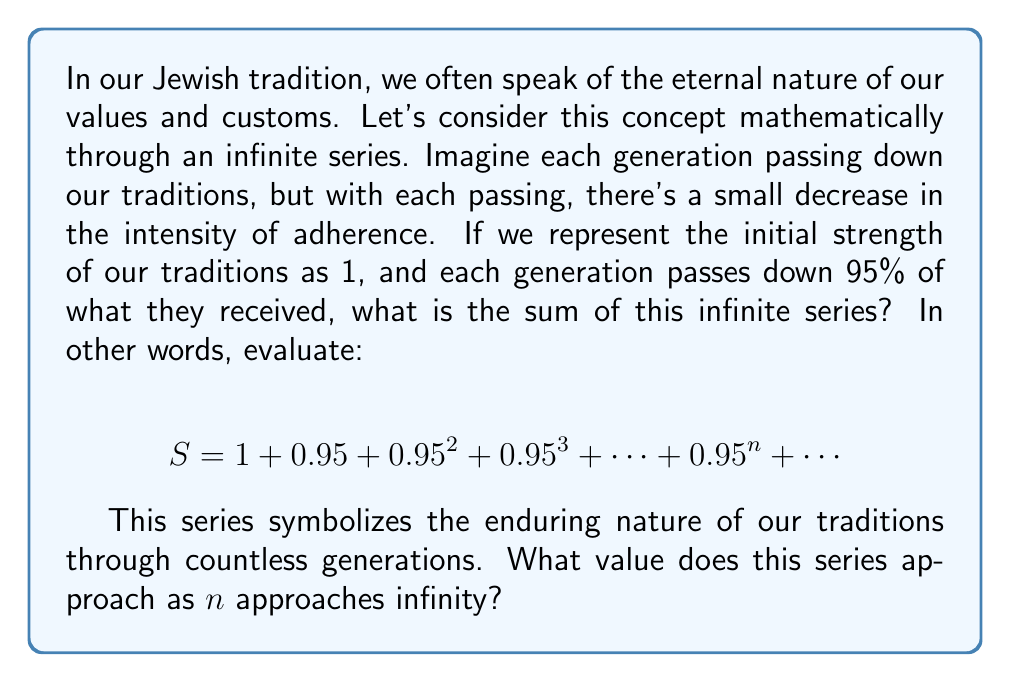Could you help me with this problem? To solve this problem, we'll use the formula for the sum of an infinite geometric series. Let's break it down step-by-step:

1) First, recall the formula for the sum of an infinite geometric series:

   $$ S_{\infty} = \frac{a}{1-r} $$

   Where $a$ is the first term and $r$ is the common ratio between terms.

2) In our series:
   - The first term, $a = 1$
   - The common ratio, $r = 0.95$

3) Let's check if $|r| < 1$, which is necessary for the series to converge:
   
   $|0.95| = 0.95 < 1$, so the series converges.

4) Now, let's substitute these values into our formula:

   $$ S_{\infty} = \frac{1}{1-0.95} = \frac{1}{0.05} = 20 $$

5) Therefore, the sum of this infinite series is 20.

This result has a beautiful interpretation in our context: Despite the gradual decrease in each generation, the cumulative impact of our traditions over infinite generations is finite and substantial - 20 times the initial strength. This symbolizes how our values and traditions, though slightly diminished in each passing, maintain a strong and lasting influence through eternity.
Answer: $$ S_{\infty} = 20 $$ 